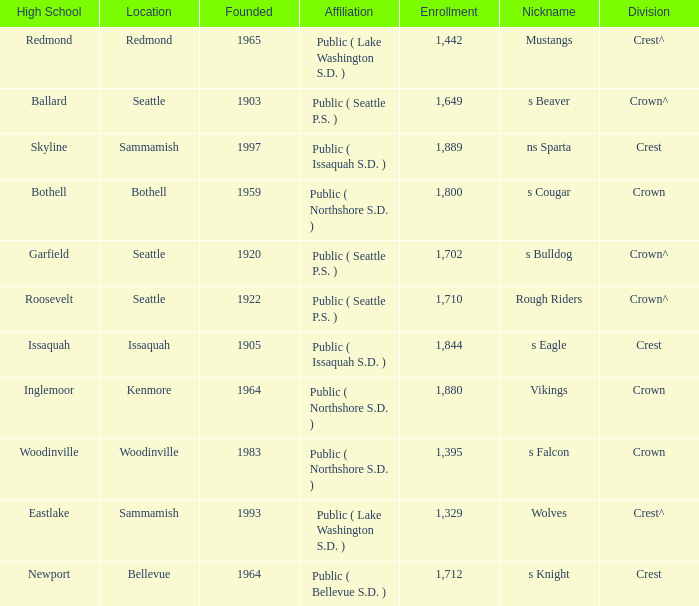What is the affiliation of a location called Issaquah? Public ( Issaquah S.D. ). 